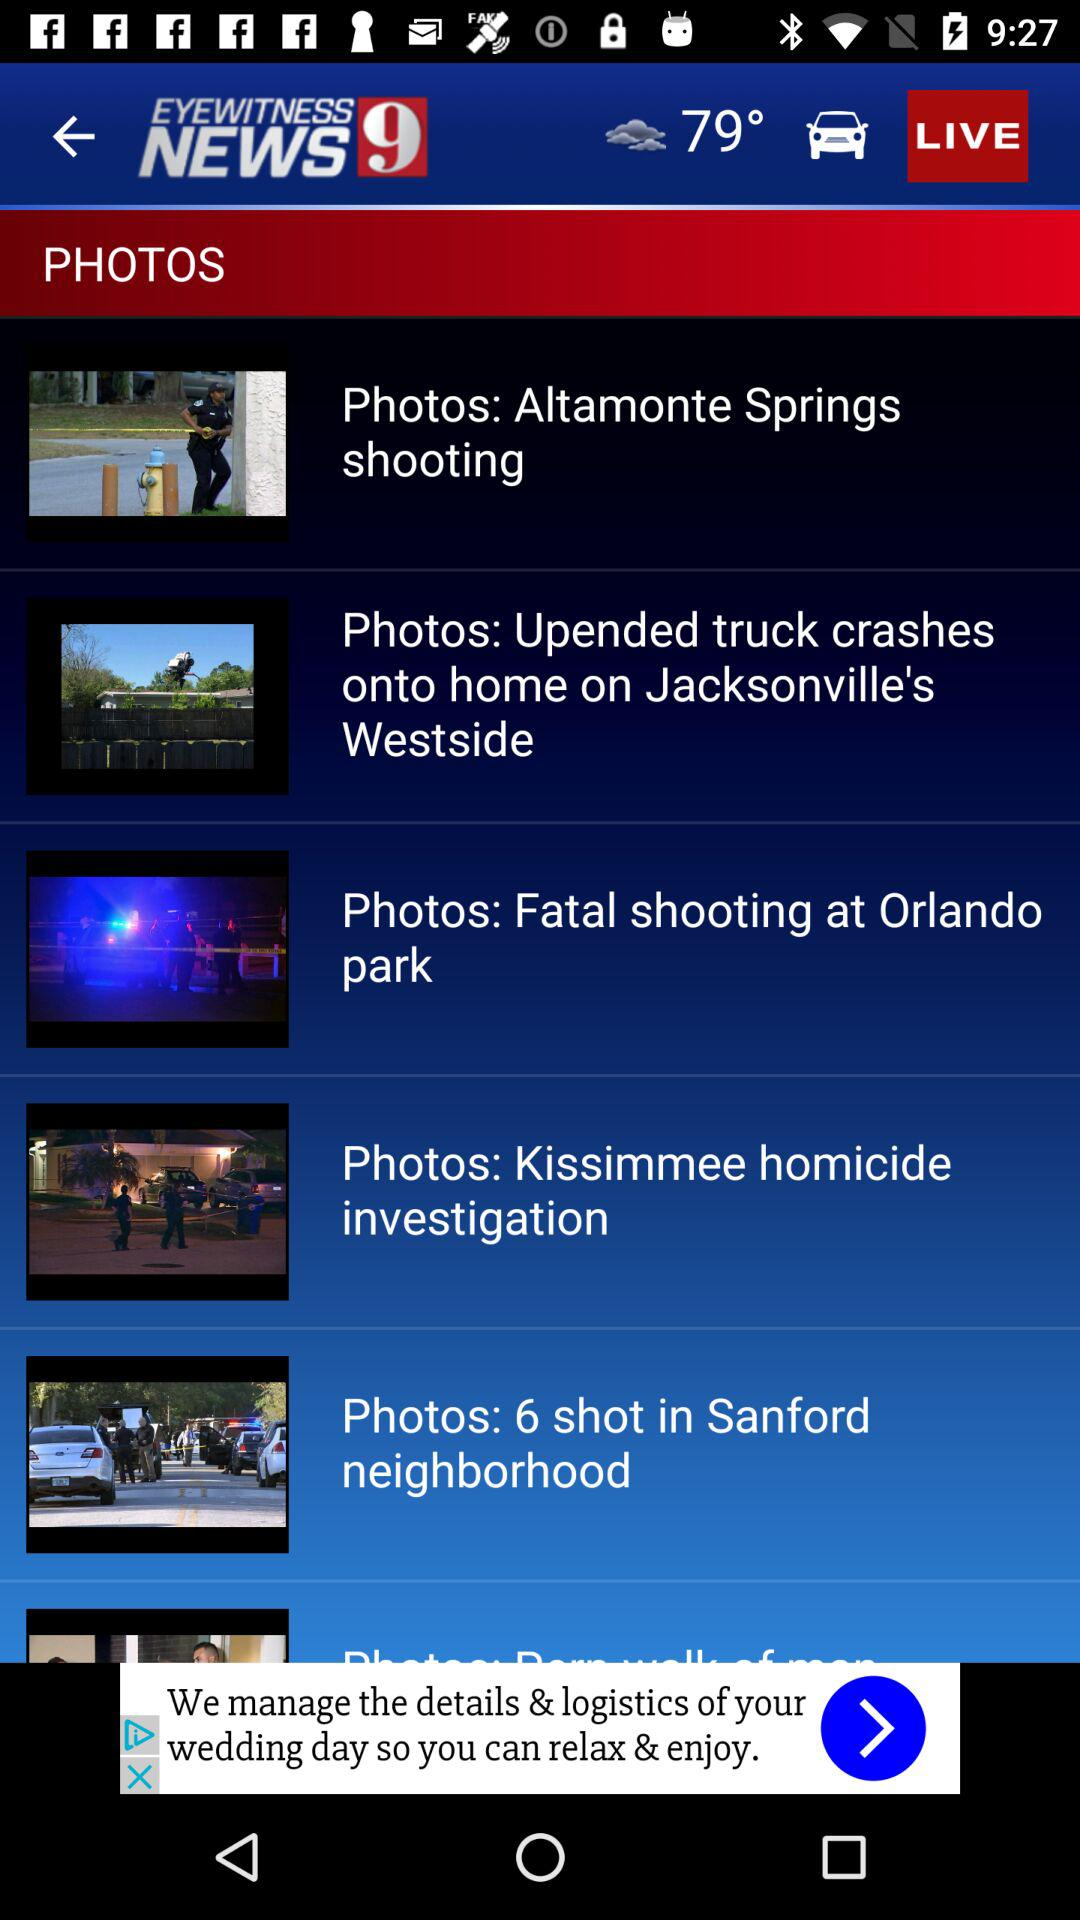What is the temperature? The temperature is 79°. 